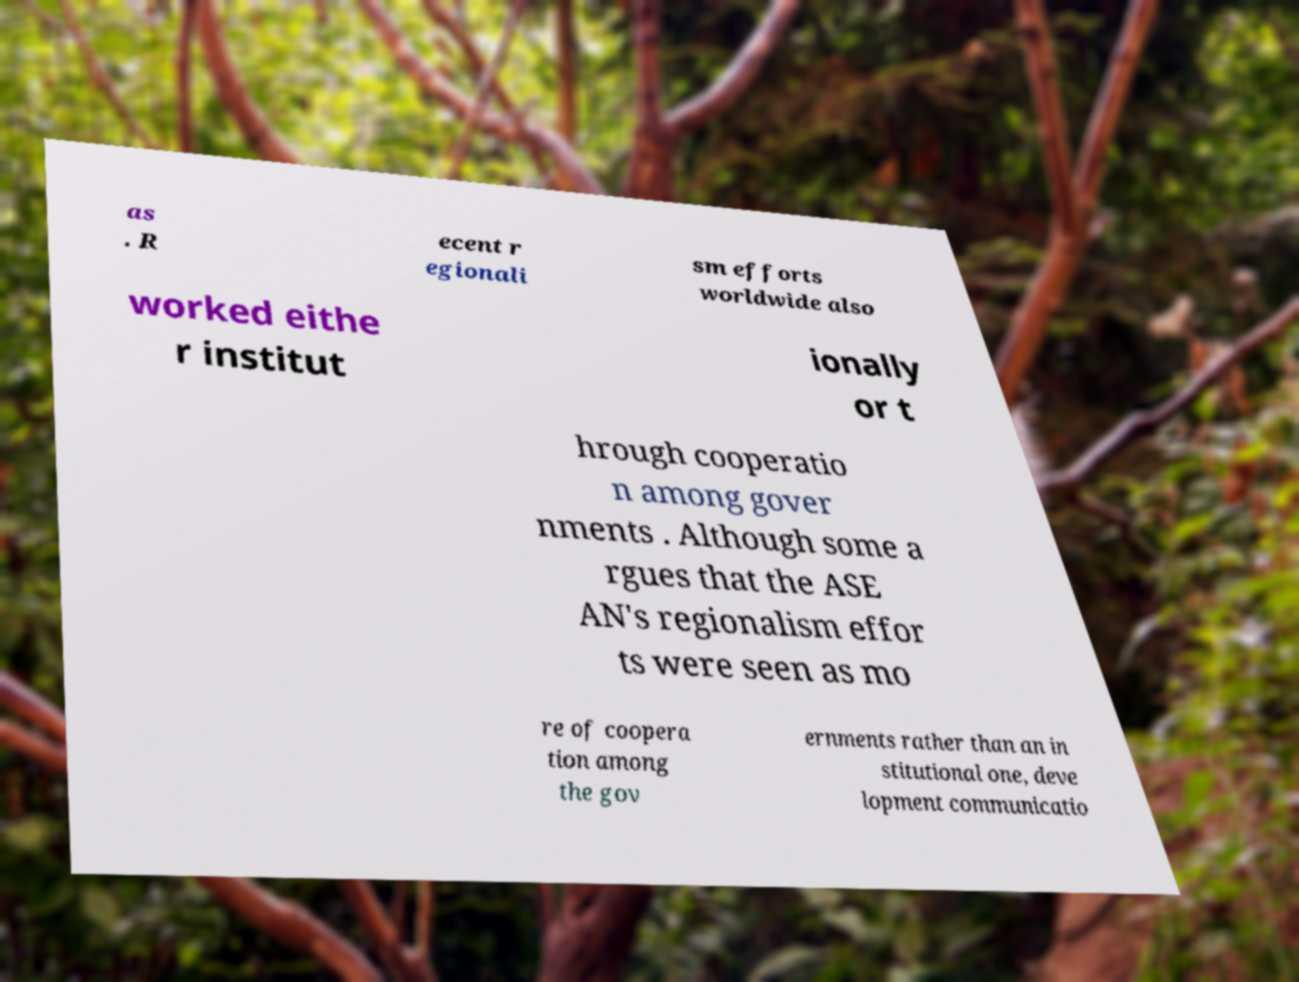For documentation purposes, I need the text within this image transcribed. Could you provide that? as . R ecent r egionali sm efforts worldwide also worked eithe r institut ionally or t hrough cooperatio n among gover nments . Although some a rgues that the ASE AN's regionalism effor ts were seen as mo re of coopera tion among the gov ernments rather than an in stitutional one, deve lopment communicatio 